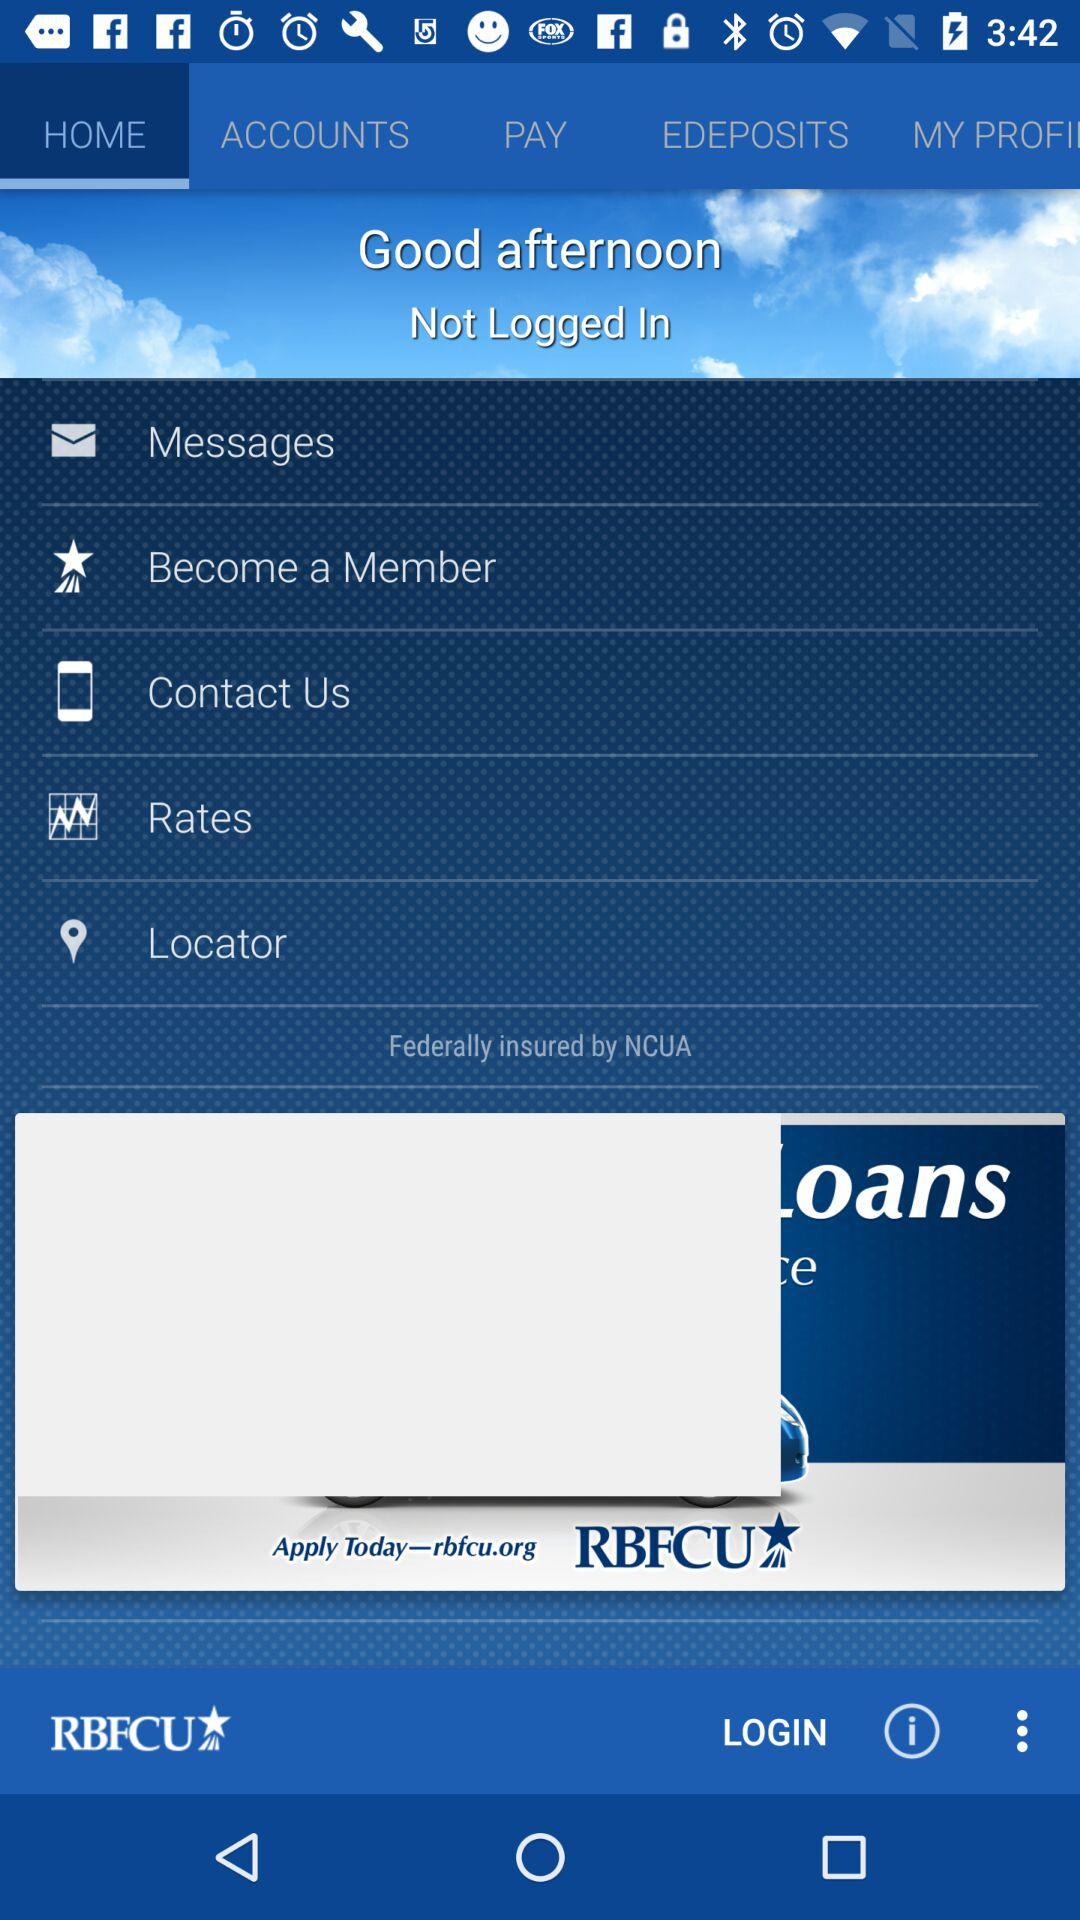Where is the nearest location?
When the provided information is insufficient, respond with <no answer>. <no answer> 